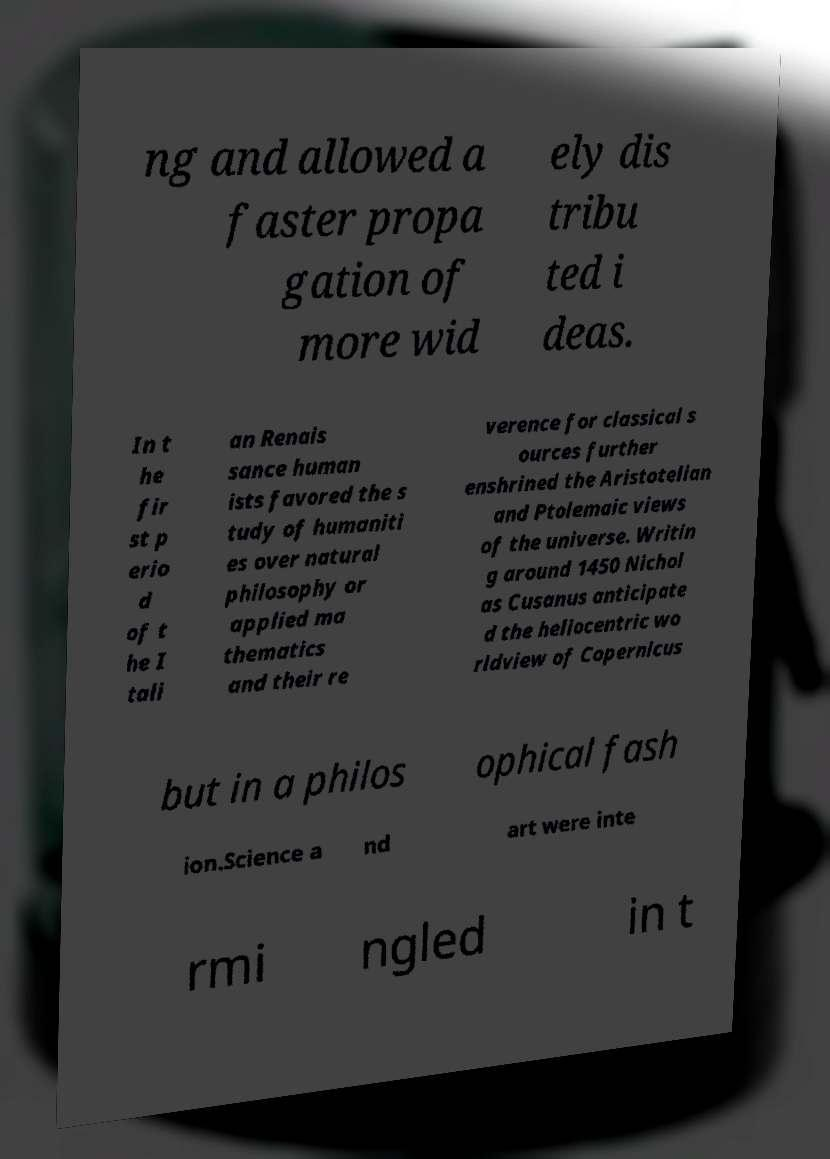What messages or text are displayed in this image? I need them in a readable, typed format. ng and allowed a faster propa gation of more wid ely dis tribu ted i deas. In t he fir st p erio d of t he I tali an Renais sance human ists favored the s tudy of humaniti es over natural philosophy or applied ma thematics and their re verence for classical s ources further enshrined the Aristotelian and Ptolemaic views of the universe. Writin g around 1450 Nichol as Cusanus anticipate d the heliocentric wo rldview of Copernicus but in a philos ophical fash ion.Science a nd art were inte rmi ngled in t 